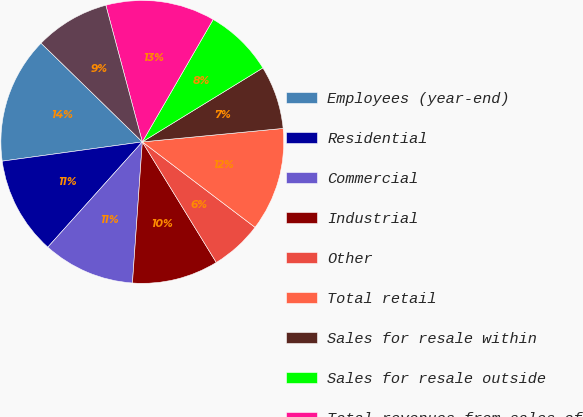Convert chart. <chart><loc_0><loc_0><loc_500><loc_500><pie_chart><fcel>Employees (year-end)<fcel>Residential<fcel>Commercial<fcel>Industrial<fcel>Other<fcel>Total retail<fcel>Sales for resale within<fcel>Sales for resale outside<fcel>Total revenues from sales of<fcel>Other revenues<nl><fcel>14.47%<fcel>11.18%<fcel>10.53%<fcel>9.87%<fcel>5.92%<fcel>11.84%<fcel>7.24%<fcel>7.89%<fcel>12.5%<fcel>8.55%<nl></chart> 